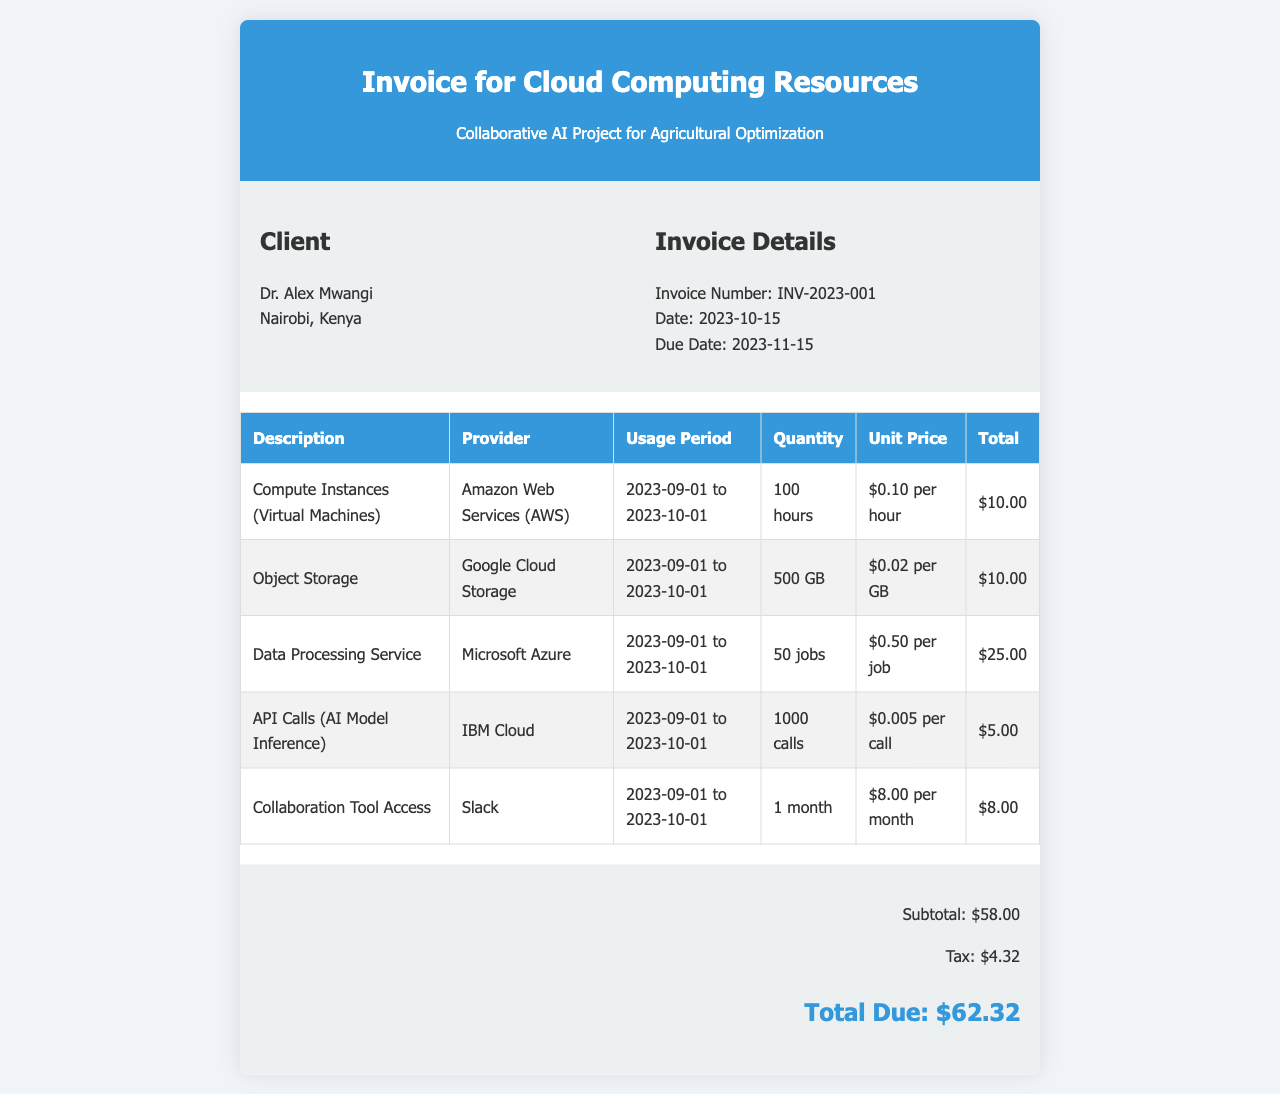What is the invoice number? The invoice number is provided in the invoice details section, which is INV-2023-001.
Answer: INV-2023-001 Who is the client? The client information includes the name, which is Dr. Alex Mwangi.
Answer: Dr. Alex Mwangi What is the total due amount? The total due amount is listed in the summary section, which shows the total as $62.32.
Answer: $62.32 Which service had the highest total cost? The service with the highest total cost can be determined by comparing the total values in the services table, which is Data Processing Service for $25.00.
Answer: Data Processing Service What is the due date for the invoice? The due date is specified in the invoice details section, which is 2023-11-15.
Answer: 2023-11-15 How many API calls were made? The quantity for API calls is listed in the services table, specifically showing 1000 calls were utilized.
Answer: 1000 calls What is the usage period for the compute instances? The usage period for the compute instances is provided in the services table, indicated as 2023-09-01 to 2023-10-01.
Answer: 2023-09-01 to 2023-10-01 What is the tax amount? The tax amount is detailed in the summary, specifically indicating a tax of $4.32.
Answer: $4.32 Which collaboration tool was used? The collaboration tool information is presented in the services table, specifying Slack as the tool.
Answer: Slack 